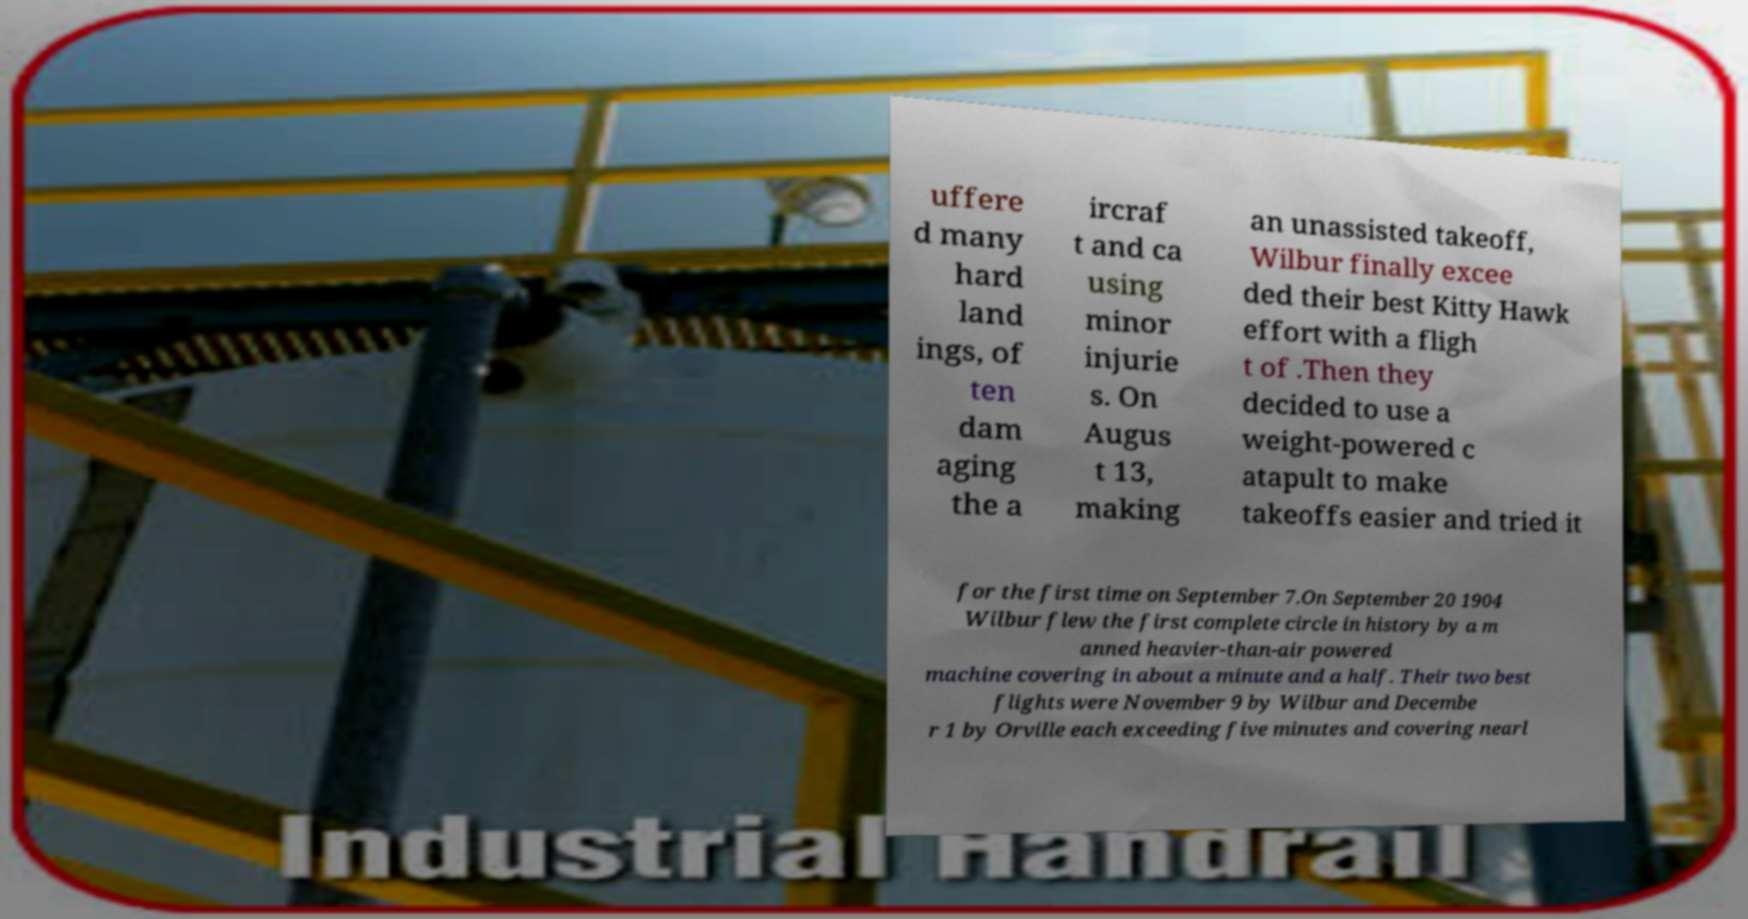Could you extract and type out the text from this image? uffere d many hard land ings, of ten dam aging the a ircraf t and ca using minor injurie s. On Augus t 13, making an unassisted takeoff, Wilbur finally excee ded their best Kitty Hawk effort with a fligh t of .Then they decided to use a weight-powered c atapult to make takeoffs easier and tried it for the first time on September 7.On September 20 1904 Wilbur flew the first complete circle in history by a m anned heavier-than-air powered machine covering in about a minute and a half. Their two best flights were November 9 by Wilbur and Decembe r 1 by Orville each exceeding five minutes and covering nearl 